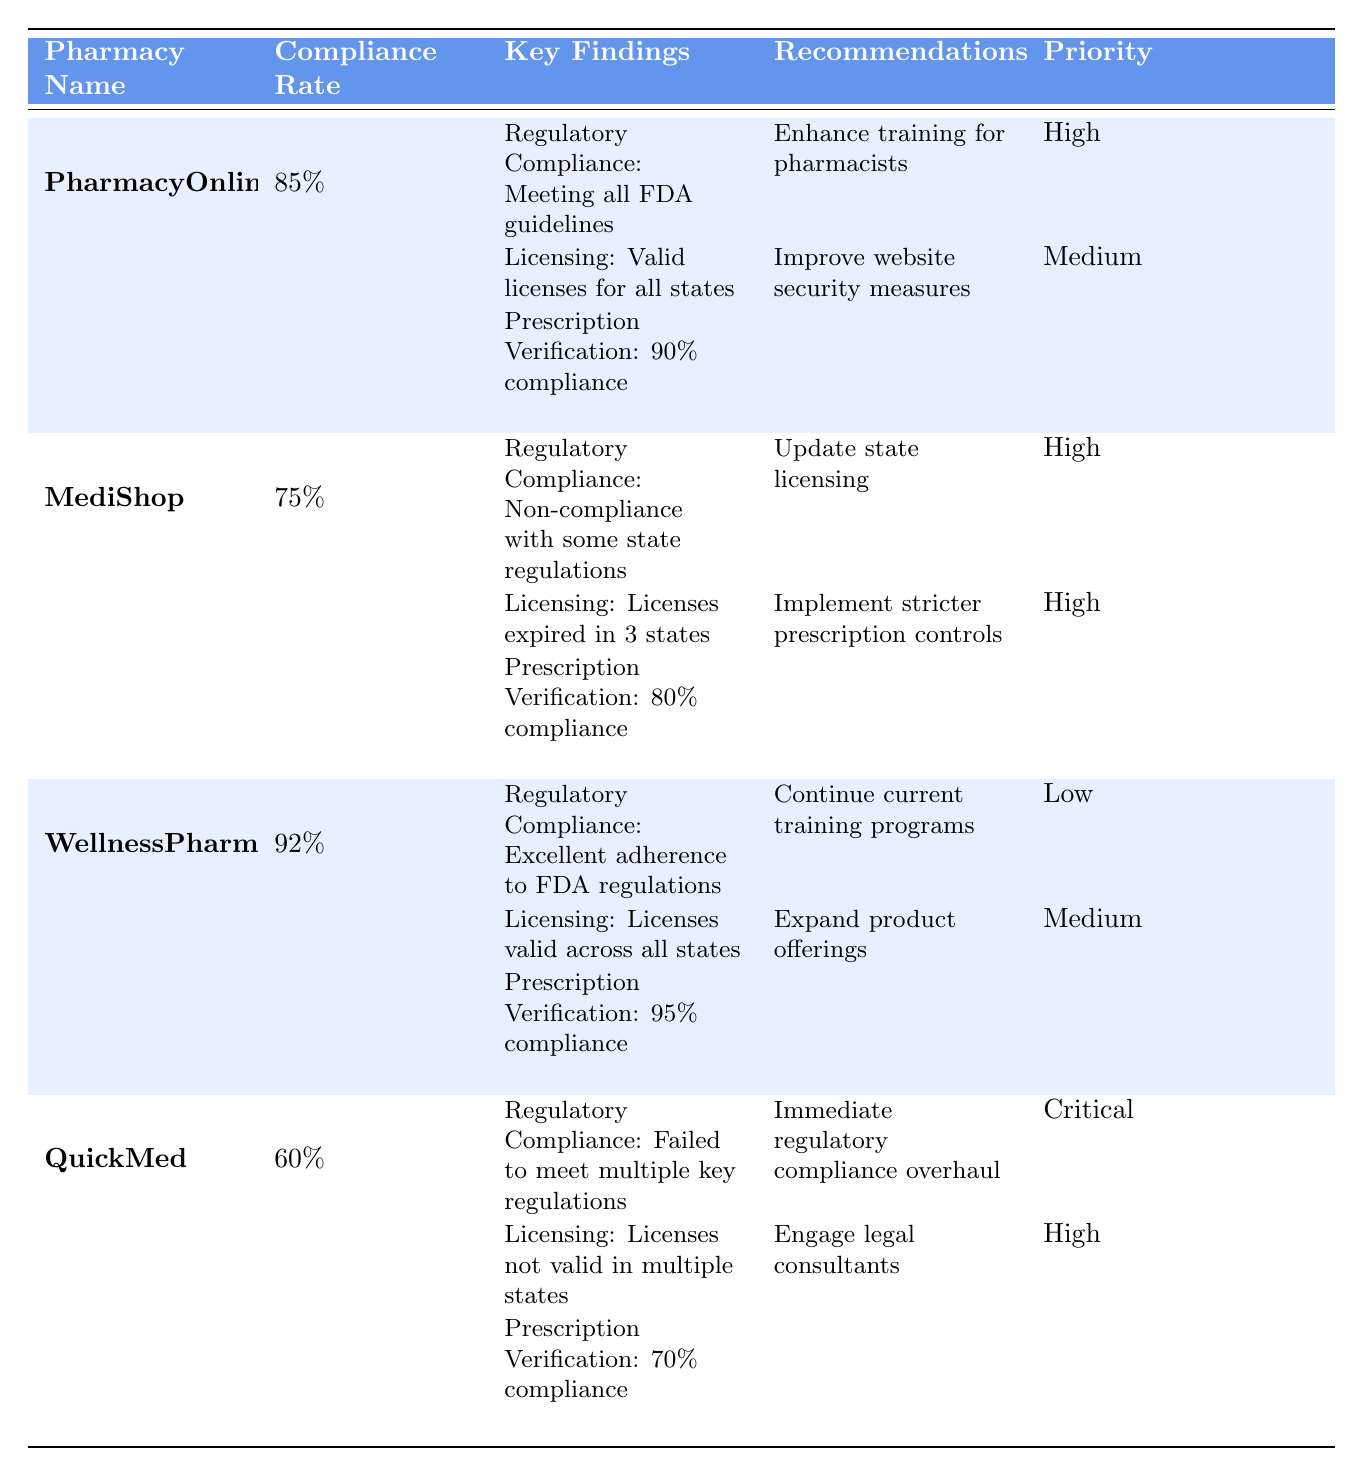What is the compliance rate for WellnessPharma? The compliance rate for WellnessPharma is listed directly in the table under the Compliance Rate column, which shows 92%.
Answer: 92% Which pharmacy has the lowest compliance rate? By comparing the compliance rates in the table, QuickMed has the lowest compliance rate at 60%.
Answer: QuickMed Is it true that all pharmacies have valid licenses for all states? Checking the Licensing key finding for each pharmacy, PharmacyOnline and WellnessPharma have valid licenses for all states, but MediShop has licenses expired in 3 states, and QuickMed has licenses not valid in multiple states. Therefore, not all pharmacies have valid licenses.
Answer: No What is the average compliance rate of the audited pharmacies? The compliance rates are 85% (PharmacyOnline), 75% (MediShop), 92% (WellnessPharma), and 60% (QuickMed). Summing these rates gives 85 + 75 + 92 + 60 = 312. Dividing by the number of pharmacies (4) gives 312 / 4 = 78.
Answer: 78% Which recommendations were classified as high priority? Looking at the Recommendations priority for each pharmacy, PharmacyOnline has "Enhance training for pharmacists" (high), MediShop has "Update state licensing" (high) and "Implement stricter prescription controls" (high), and QuickMed has "Engage legal consultants" (high).
Answer: Enhance training for pharmacists; Update state licensing; Implement stricter prescription controls; Engage legal consultants What percentage of prescription verification compliance does MediShop achieve? From the Key Findings of MediShop in the table, the Prescription Verification compliance is stated as 80%.
Answer: 80% How many pharmacies have a compliance rate over 80%? The pharmacies with compliance rates over 80% are PharmacyOnline (85%) and WellnessPharma (92%). Counting these, there are 2 pharmacies.
Answer: 2 What is the regulatory compliance status of QuickMed? The Key Findings for QuickMed indicate that it has failed to meet multiple key regulations, which reflects its poor regulatory compliance status.
Answer: Failed to meet multiple key regulations 